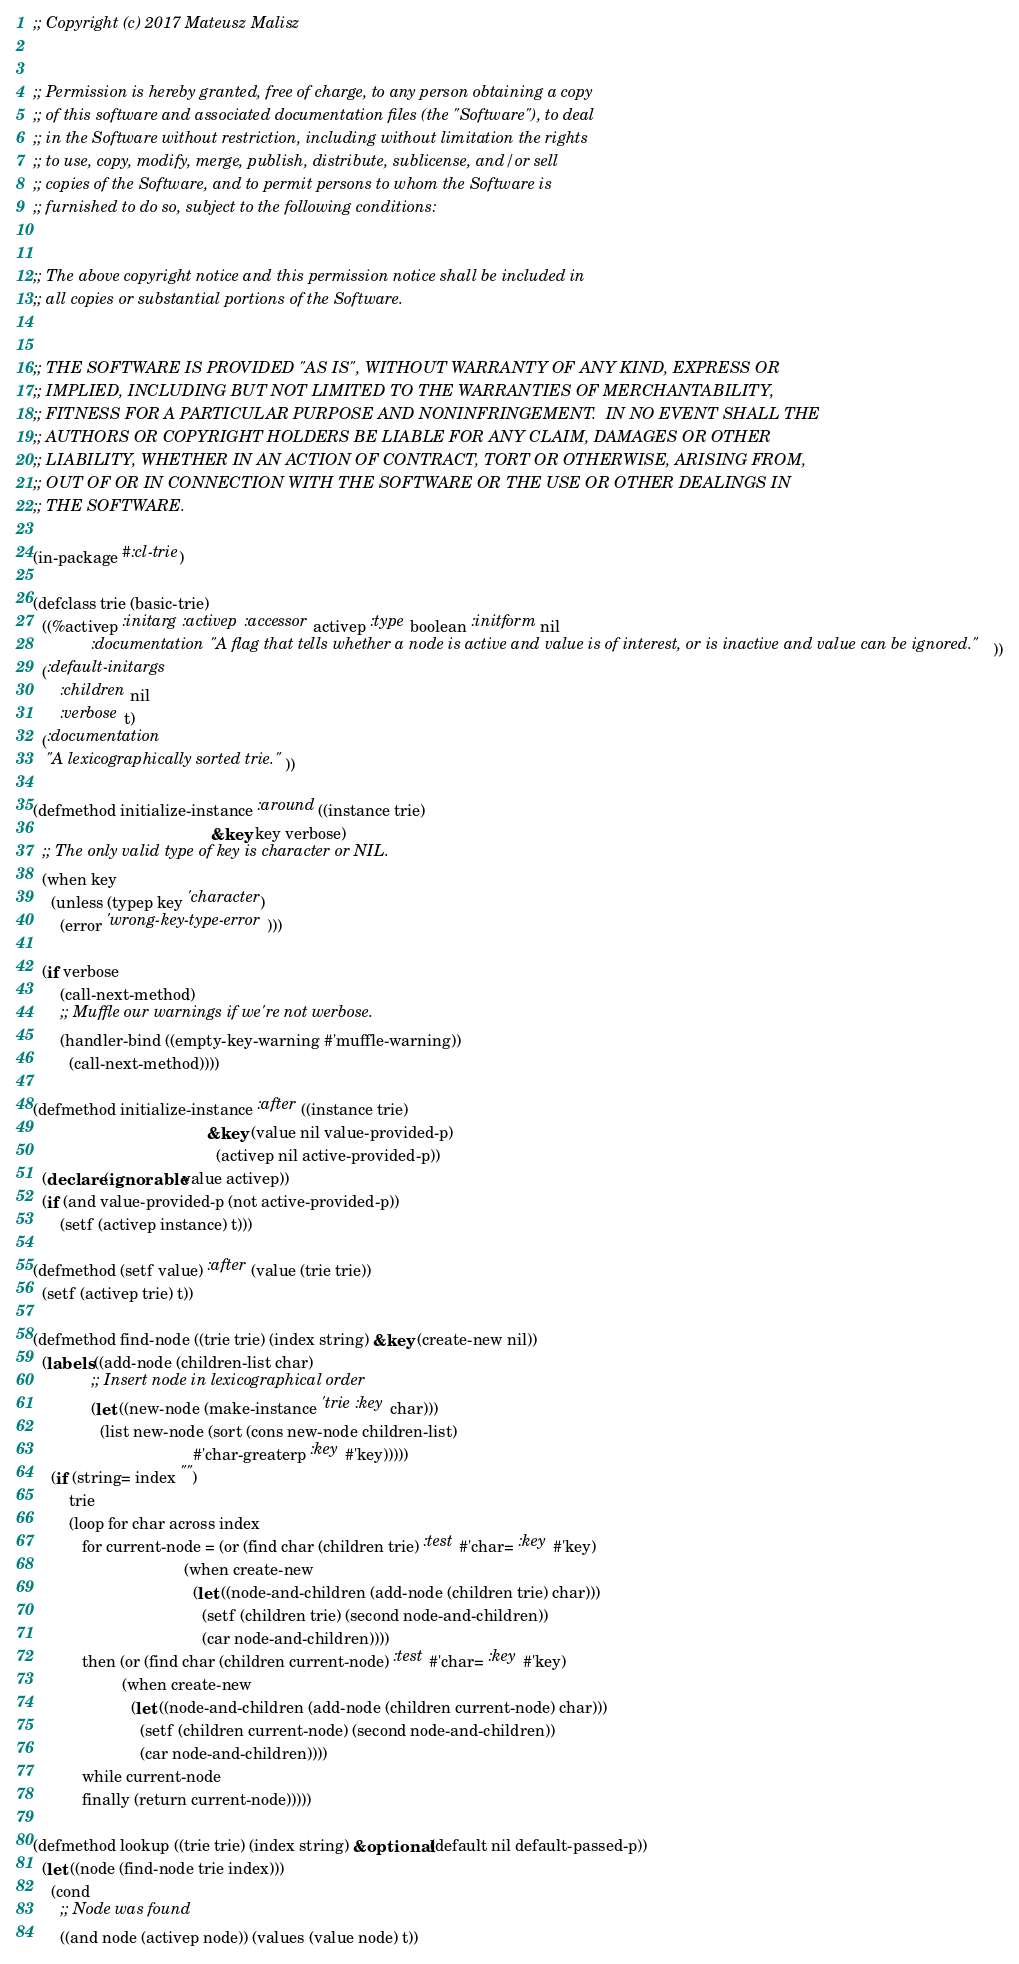<code> <loc_0><loc_0><loc_500><loc_500><_Lisp_>;; Copyright (c) 2017 Mateusz Malisz


;; Permission is hereby granted, free of charge, to any person obtaining a copy
;; of this software and associated documentation files (the "Software"), to deal
;; in the Software without restriction, including without limitation the rights
;; to use, copy, modify, merge, publish, distribute, sublicense, and/or sell
;; copies of the Software, and to permit persons to whom the Software is
;; furnished to do so, subject to the following conditions:


;; The above copyright notice and this permission notice shall be included in
;; all copies or substantial portions of the Software.


;; THE SOFTWARE IS PROVIDED "AS IS", WITHOUT WARRANTY OF ANY KIND, EXPRESS OR
;; IMPLIED, INCLUDING BUT NOT LIMITED TO THE WARRANTIES OF MERCHANTABILITY,
;; FITNESS FOR A PARTICULAR PURPOSE AND NONINFRINGEMENT.  IN NO EVENT SHALL THE
;; AUTHORS OR COPYRIGHT HOLDERS BE LIABLE FOR ANY CLAIM, DAMAGES OR OTHER
;; LIABILITY, WHETHER IN AN ACTION OF CONTRACT, TORT OR OTHERWISE, ARISING FROM,
;; OUT OF OR IN CONNECTION WITH THE SOFTWARE OR THE USE OR OTHER DEALINGS IN
;; THE SOFTWARE.

(in-package #:cl-trie)

(defclass trie (basic-trie)
  ((%activep :initarg :activep :accessor activep :type boolean :initform nil
             :documentation "A flag that tells whether a node is active and value is of interest, or is inactive and value can be ignored."))
  (:default-initargs
      :children nil
      :verbose t)
  (:documentation
   "A lexicographically sorted trie."))

(defmethod initialize-instance :around ((instance trie)
                                        &key key verbose)
  ;; The only valid type of key is character or NIL.
  (when key
    (unless (typep key 'character)
      (error 'wrong-key-type-error)))

  (if verbose
      (call-next-method)
      ;; Muffle our warnings if we're not werbose.
      (handler-bind ((empty-key-warning #'muffle-warning))
        (call-next-method))))

(defmethod initialize-instance :after ((instance trie)
                                       &key (value nil value-provided-p)
                                         (activep nil active-provided-p))
  (declare (ignorable value activep))
  (if (and value-provided-p (not active-provided-p))
      (setf (activep instance) t)))

(defmethod (setf value) :after (value (trie trie))
  (setf (activep trie) t))

(defmethod find-node ((trie trie) (index string) &key (create-new nil))
  (labels ((add-node (children-list char)
             ;; Insert node in lexicographical order
             (let ((new-node (make-instance 'trie :key char)))
               (list new-node (sort (cons new-node children-list)
                                    #'char-greaterp :key #'key)))))
    (if (string= index "")
        trie
        (loop for char across index
           for current-node = (or (find char (children trie) :test #'char= :key #'key)
                                  (when create-new
                                    (let ((node-and-children (add-node (children trie) char)))
                                      (setf (children trie) (second node-and-children))
                                      (car node-and-children))))
           then (or (find char (children current-node) :test #'char= :key #'key)
                    (when create-new
                      (let ((node-and-children (add-node (children current-node) char)))
                        (setf (children current-node) (second node-and-children))
                        (car node-and-children))))
           while current-node
           finally (return current-node)))))

(defmethod lookup ((trie trie) (index string) &optional (default nil default-passed-p))
  (let ((node (find-node trie index)))
    (cond
      ;; Node was found
      ((and node (activep node)) (values (value node) t))</code> 